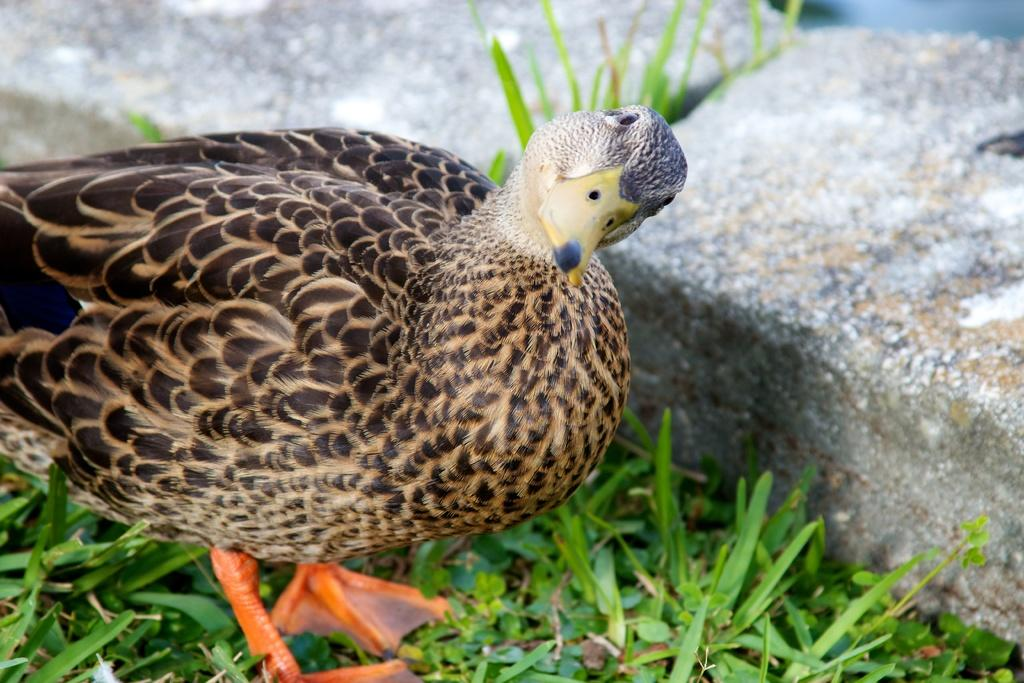What is the main subject of the image? There is a bird in the center of the image. What is the bird standing on? The bird is standing on the grass. What can be seen in the background of the image? There are stones visible in the background of the image. What type of fear does the bird have in the image? There is no indication of fear in the image; the bird is simply standing on the grass. What is the bird serving for dinner in the image? There is no dinner or food-related activity depicted in the image; it only shows a bird standing on the grass. 